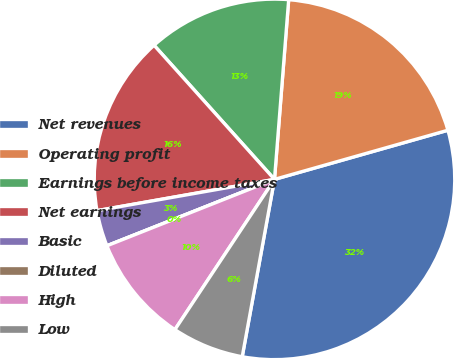Convert chart to OTSL. <chart><loc_0><loc_0><loc_500><loc_500><pie_chart><fcel>Net revenues<fcel>Operating profit<fcel>Earnings before income taxes<fcel>Net earnings<fcel>Basic<fcel>Diluted<fcel>High<fcel>Low<nl><fcel>32.26%<fcel>19.35%<fcel>12.9%<fcel>16.13%<fcel>3.23%<fcel>0.0%<fcel>9.68%<fcel>6.45%<nl></chart> 